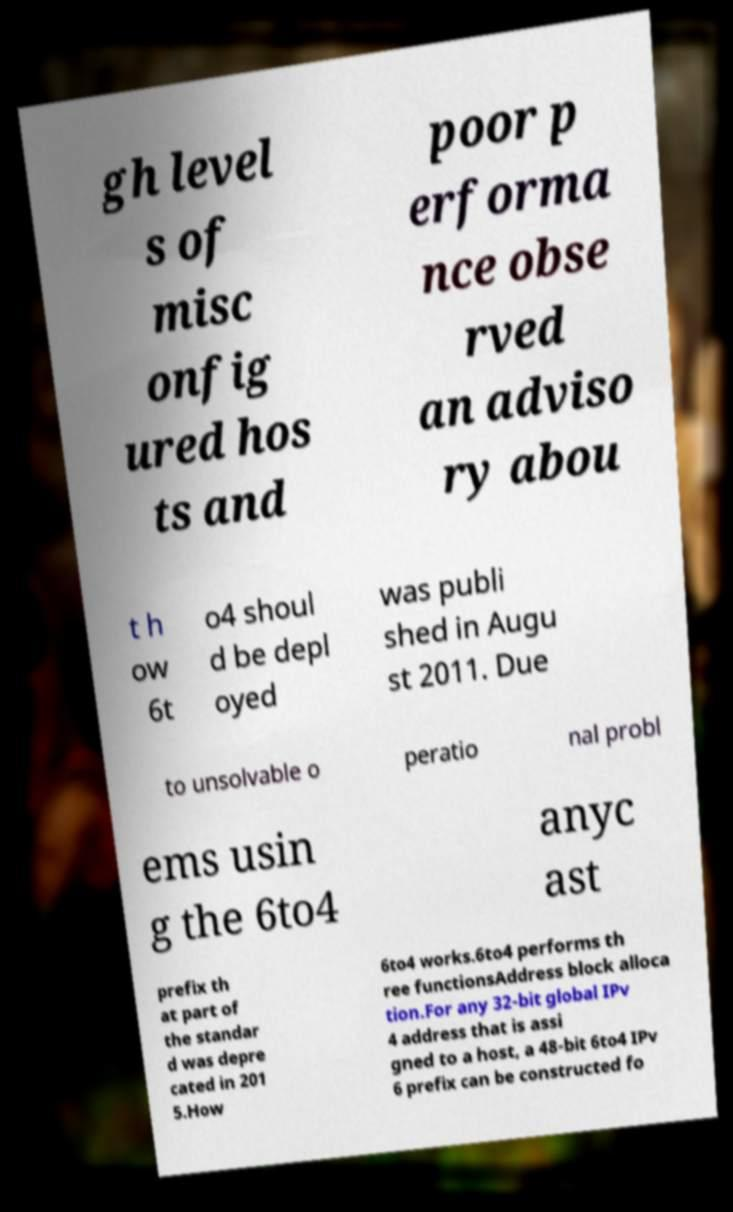Please read and relay the text visible in this image. What does it say? gh level s of misc onfig ured hos ts and poor p erforma nce obse rved an adviso ry abou t h ow 6t o4 shoul d be depl oyed was publi shed in Augu st 2011. Due to unsolvable o peratio nal probl ems usin g the 6to4 anyc ast prefix th at part of the standar d was depre cated in 201 5.How 6to4 works.6to4 performs th ree functionsAddress block alloca tion.For any 32-bit global IPv 4 address that is assi gned to a host, a 48-bit 6to4 IPv 6 prefix can be constructed fo 